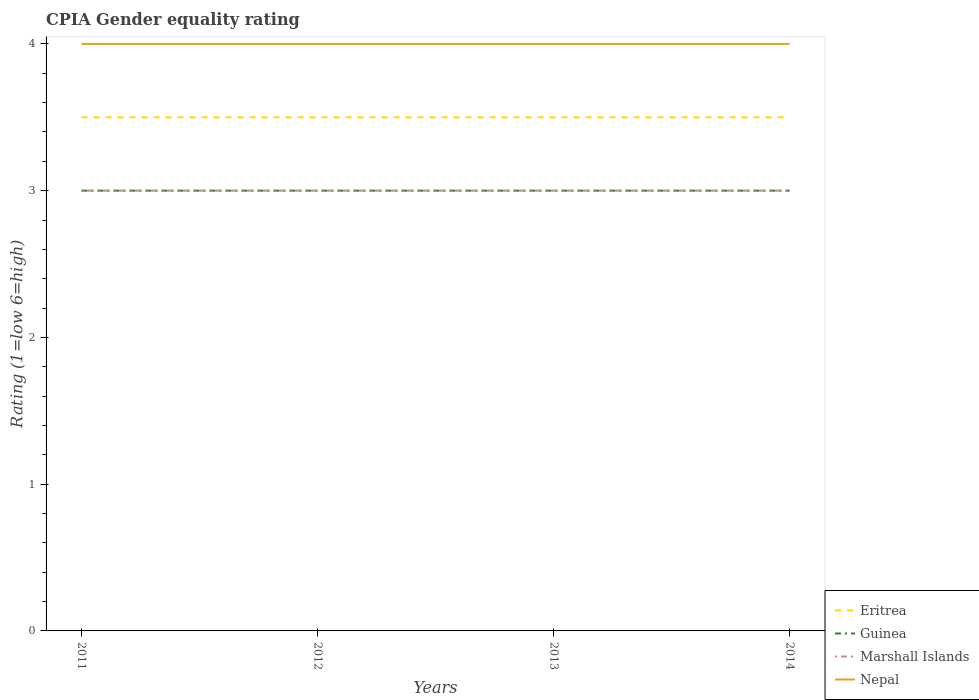How many different coloured lines are there?
Keep it short and to the point. 4. In which year was the CPIA rating in Marshall Islands maximum?
Your answer should be compact. 2011. What is the difference between the highest and the second highest CPIA rating in Eritrea?
Provide a short and direct response. 0. What is the difference between the highest and the lowest CPIA rating in Nepal?
Provide a succinct answer. 0. Is the CPIA rating in Guinea strictly greater than the CPIA rating in Nepal over the years?
Ensure brevity in your answer.  Yes. How many lines are there?
Offer a very short reply. 4. How many years are there in the graph?
Keep it short and to the point. 4. What is the difference between two consecutive major ticks on the Y-axis?
Keep it short and to the point. 1. Does the graph contain grids?
Keep it short and to the point. No. Where does the legend appear in the graph?
Your response must be concise. Bottom right. How many legend labels are there?
Give a very brief answer. 4. What is the title of the graph?
Your answer should be compact. CPIA Gender equality rating. What is the label or title of the X-axis?
Your response must be concise. Years. What is the Rating (1=low 6=high) in Nepal in 2011?
Offer a terse response. 4. What is the Rating (1=low 6=high) in Eritrea in 2012?
Give a very brief answer. 3.5. What is the Rating (1=low 6=high) of Guinea in 2013?
Ensure brevity in your answer.  3. What is the Rating (1=low 6=high) in Marshall Islands in 2013?
Your answer should be compact. 3. What is the Rating (1=low 6=high) of Guinea in 2014?
Offer a terse response. 3. Across all years, what is the maximum Rating (1=low 6=high) in Eritrea?
Make the answer very short. 3.5. Across all years, what is the maximum Rating (1=low 6=high) in Guinea?
Your response must be concise. 3. Across all years, what is the maximum Rating (1=low 6=high) of Nepal?
Your answer should be compact. 4. Across all years, what is the minimum Rating (1=low 6=high) of Guinea?
Your response must be concise. 3. Across all years, what is the minimum Rating (1=low 6=high) of Nepal?
Offer a terse response. 4. What is the total Rating (1=low 6=high) in Eritrea in the graph?
Provide a short and direct response. 14. What is the total Rating (1=low 6=high) in Guinea in the graph?
Your answer should be compact. 12. What is the total Rating (1=low 6=high) in Nepal in the graph?
Make the answer very short. 16. What is the difference between the Rating (1=low 6=high) in Guinea in 2011 and that in 2012?
Your answer should be compact. 0. What is the difference between the Rating (1=low 6=high) in Nepal in 2011 and that in 2012?
Give a very brief answer. 0. What is the difference between the Rating (1=low 6=high) in Eritrea in 2011 and that in 2013?
Give a very brief answer. 0. What is the difference between the Rating (1=low 6=high) of Guinea in 2011 and that in 2013?
Your answer should be very brief. 0. What is the difference between the Rating (1=low 6=high) of Marshall Islands in 2011 and that in 2013?
Your response must be concise. 0. What is the difference between the Rating (1=low 6=high) in Nepal in 2011 and that in 2013?
Provide a succinct answer. 0. What is the difference between the Rating (1=low 6=high) in Marshall Islands in 2011 and that in 2014?
Your answer should be very brief. 0. What is the difference between the Rating (1=low 6=high) in Nepal in 2011 and that in 2014?
Your answer should be compact. 0. What is the difference between the Rating (1=low 6=high) of Guinea in 2012 and that in 2013?
Make the answer very short. 0. What is the difference between the Rating (1=low 6=high) of Eritrea in 2012 and that in 2014?
Give a very brief answer. 0. What is the difference between the Rating (1=low 6=high) of Guinea in 2012 and that in 2014?
Offer a terse response. 0. What is the difference between the Rating (1=low 6=high) in Eritrea in 2013 and that in 2014?
Your answer should be compact. 0. What is the difference between the Rating (1=low 6=high) of Guinea in 2013 and that in 2014?
Keep it short and to the point. 0. What is the difference between the Rating (1=low 6=high) of Marshall Islands in 2013 and that in 2014?
Provide a succinct answer. 0. What is the difference between the Rating (1=low 6=high) in Eritrea in 2011 and the Rating (1=low 6=high) in Marshall Islands in 2012?
Offer a very short reply. 0.5. What is the difference between the Rating (1=low 6=high) in Eritrea in 2011 and the Rating (1=low 6=high) in Nepal in 2012?
Your response must be concise. -0.5. What is the difference between the Rating (1=low 6=high) of Guinea in 2011 and the Rating (1=low 6=high) of Marshall Islands in 2012?
Make the answer very short. 0. What is the difference between the Rating (1=low 6=high) of Guinea in 2011 and the Rating (1=low 6=high) of Nepal in 2012?
Offer a terse response. -1. What is the difference between the Rating (1=low 6=high) of Eritrea in 2011 and the Rating (1=low 6=high) of Guinea in 2013?
Provide a succinct answer. 0.5. What is the difference between the Rating (1=low 6=high) in Eritrea in 2011 and the Rating (1=low 6=high) in Marshall Islands in 2013?
Provide a succinct answer. 0.5. What is the difference between the Rating (1=low 6=high) in Eritrea in 2011 and the Rating (1=low 6=high) in Nepal in 2013?
Provide a short and direct response. -0.5. What is the difference between the Rating (1=low 6=high) in Guinea in 2011 and the Rating (1=low 6=high) in Marshall Islands in 2013?
Provide a short and direct response. 0. What is the difference between the Rating (1=low 6=high) in Guinea in 2011 and the Rating (1=low 6=high) in Nepal in 2013?
Ensure brevity in your answer.  -1. What is the difference between the Rating (1=low 6=high) of Eritrea in 2011 and the Rating (1=low 6=high) of Guinea in 2014?
Your answer should be very brief. 0.5. What is the difference between the Rating (1=low 6=high) of Eritrea in 2011 and the Rating (1=low 6=high) of Marshall Islands in 2014?
Provide a succinct answer. 0.5. What is the difference between the Rating (1=low 6=high) of Eritrea in 2011 and the Rating (1=low 6=high) of Nepal in 2014?
Provide a succinct answer. -0.5. What is the difference between the Rating (1=low 6=high) in Guinea in 2011 and the Rating (1=low 6=high) in Marshall Islands in 2014?
Offer a terse response. 0. What is the difference between the Rating (1=low 6=high) of Guinea in 2011 and the Rating (1=low 6=high) of Nepal in 2014?
Offer a very short reply. -1. What is the difference between the Rating (1=low 6=high) in Eritrea in 2012 and the Rating (1=low 6=high) in Marshall Islands in 2013?
Offer a terse response. 0.5. What is the difference between the Rating (1=low 6=high) of Eritrea in 2012 and the Rating (1=low 6=high) of Nepal in 2013?
Give a very brief answer. -0.5. What is the difference between the Rating (1=low 6=high) of Guinea in 2012 and the Rating (1=low 6=high) of Marshall Islands in 2013?
Your response must be concise. 0. What is the difference between the Rating (1=low 6=high) of Eritrea in 2012 and the Rating (1=low 6=high) of Marshall Islands in 2014?
Your answer should be compact. 0.5. What is the difference between the Rating (1=low 6=high) of Eritrea in 2012 and the Rating (1=low 6=high) of Nepal in 2014?
Keep it short and to the point. -0.5. What is the average Rating (1=low 6=high) in Eritrea per year?
Keep it short and to the point. 3.5. What is the average Rating (1=low 6=high) of Nepal per year?
Offer a very short reply. 4. In the year 2011, what is the difference between the Rating (1=low 6=high) of Eritrea and Rating (1=low 6=high) of Guinea?
Offer a very short reply. 0.5. In the year 2011, what is the difference between the Rating (1=low 6=high) in Eritrea and Rating (1=low 6=high) in Marshall Islands?
Your answer should be very brief. 0.5. In the year 2011, what is the difference between the Rating (1=low 6=high) in Guinea and Rating (1=low 6=high) in Marshall Islands?
Make the answer very short. 0. In the year 2011, what is the difference between the Rating (1=low 6=high) in Guinea and Rating (1=low 6=high) in Nepal?
Make the answer very short. -1. In the year 2012, what is the difference between the Rating (1=low 6=high) in Eritrea and Rating (1=low 6=high) in Guinea?
Provide a short and direct response. 0.5. In the year 2013, what is the difference between the Rating (1=low 6=high) in Guinea and Rating (1=low 6=high) in Nepal?
Your answer should be very brief. -1. In the year 2014, what is the difference between the Rating (1=low 6=high) in Eritrea and Rating (1=low 6=high) in Nepal?
Keep it short and to the point. -0.5. In the year 2014, what is the difference between the Rating (1=low 6=high) in Guinea and Rating (1=low 6=high) in Marshall Islands?
Your response must be concise. 0. In the year 2014, what is the difference between the Rating (1=low 6=high) of Marshall Islands and Rating (1=low 6=high) of Nepal?
Offer a terse response. -1. What is the ratio of the Rating (1=low 6=high) in Marshall Islands in 2011 to that in 2012?
Give a very brief answer. 1. What is the ratio of the Rating (1=low 6=high) of Nepal in 2011 to that in 2012?
Keep it short and to the point. 1. What is the ratio of the Rating (1=low 6=high) in Nepal in 2011 to that in 2013?
Offer a terse response. 1. What is the ratio of the Rating (1=low 6=high) of Marshall Islands in 2011 to that in 2014?
Offer a terse response. 1. What is the ratio of the Rating (1=low 6=high) in Nepal in 2011 to that in 2014?
Your answer should be compact. 1. What is the ratio of the Rating (1=low 6=high) in Marshall Islands in 2012 to that in 2013?
Keep it short and to the point. 1. What is the ratio of the Rating (1=low 6=high) in Eritrea in 2012 to that in 2014?
Provide a succinct answer. 1. What is the ratio of the Rating (1=low 6=high) of Guinea in 2012 to that in 2014?
Provide a short and direct response. 1. What is the ratio of the Rating (1=low 6=high) of Nepal in 2012 to that in 2014?
Your response must be concise. 1. What is the ratio of the Rating (1=low 6=high) in Guinea in 2013 to that in 2014?
Your response must be concise. 1. What is the ratio of the Rating (1=low 6=high) of Marshall Islands in 2013 to that in 2014?
Offer a terse response. 1. What is the difference between the highest and the second highest Rating (1=low 6=high) of Eritrea?
Your answer should be very brief. 0. What is the difference between the highest and the second highest Rating (1=low 6=high) of Marshall Islands?
Your answer should be compact. 0. What is the difference between the highest and the second highest Rating (1=low 6=high) of Nepal?
Provide a succinct answer. 0. What is the difference between the highest and the lowest Rating (1=low 6=high) in Guinea?
Your response must be concise. 0. 